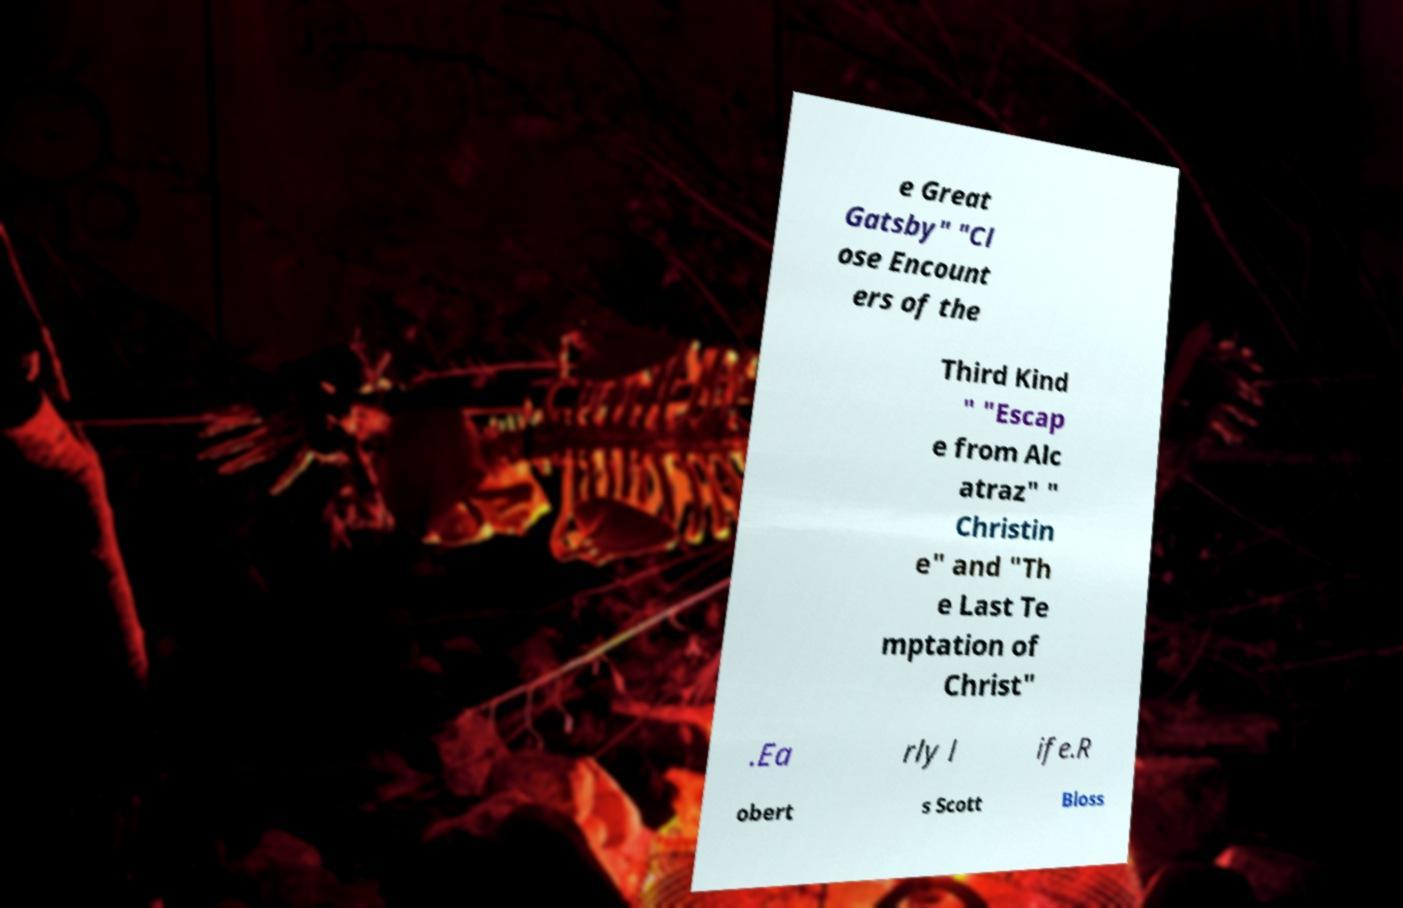Can you read and provide the text displayed in the image?This photo seems to have some interesting text. Can you extract and type it out for me? e Great Gatsby" "Cl ose Encount ers of the Third Kind " "Escap e from Alc atraz" " Christin e" and "Th e Last Te mptation of Christ" .Ea rly l ife.R obert s Scott Bloss 